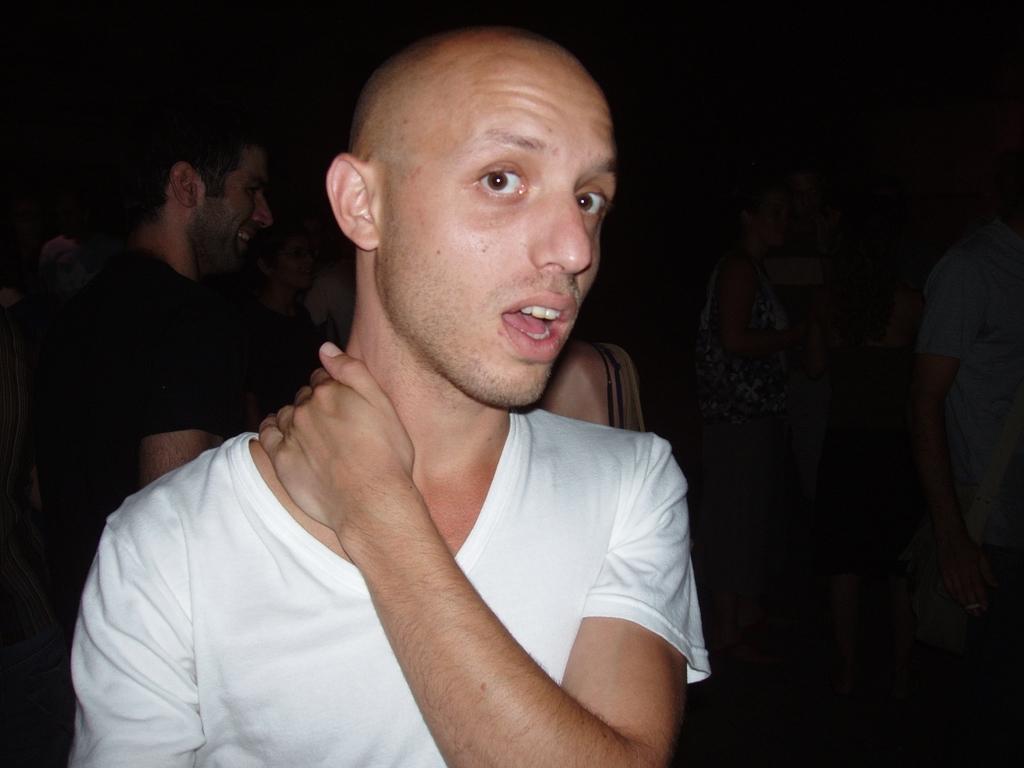Could you give a brief overview of what you see in this image? In the middle of this image, there is a person in a white color T-shirt, keeping his hand on his neck and speaking. In the background, there is another person. And the background is dark in color. 